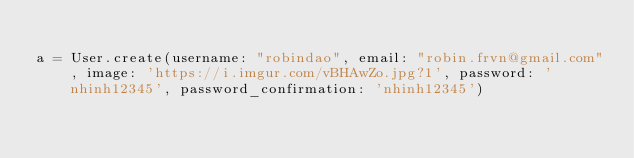Convert code to text. <code><loc_0><loc_0><loc_500><loc_500><_Ruby_>
a = User.create(username: "robindao", email: "robin.frvn@gmail.com", image: 'https://i.imgur.com/vBHAwZo.jpg?1', password: 'nhinh12345', password_confirmation: 'nhinh12345')
</code> 